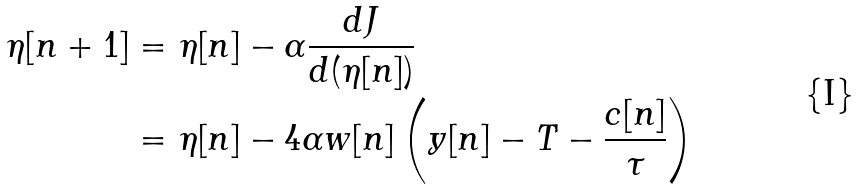<formula> <loc_0><loc_0><loc_500><loc_500>\eta [ n + 1 ] & = \eta [ n ] - \alpha \frac { d J } { d ( \eta [ n ] ) } \\ & = \eta [ n ] - 4 \alpha w [ n ] \left ( y [ n ] - T - \frac { c [ n ] } { \tau } \right )</formula> 